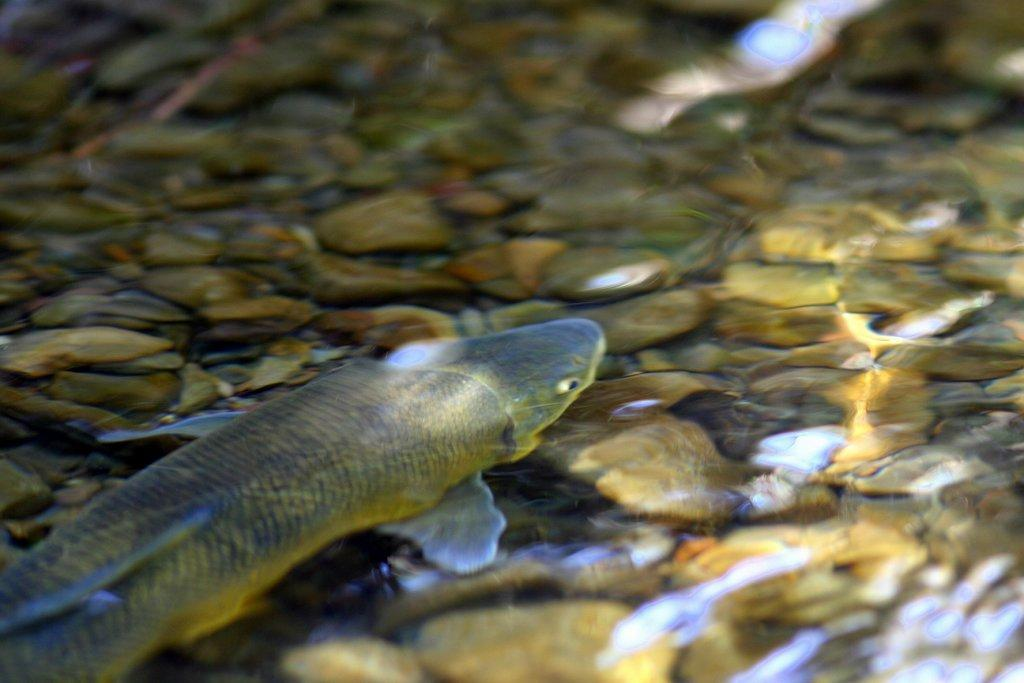What can be seen on the left side of the image? There is a fish in the water on the left side of the image. What is present under the water in the image? There are many stones under the water. How many frogs can be seen attempting to jump on the stones in the image? There are no frogs present in the image, so it is not possible to answer that question. 